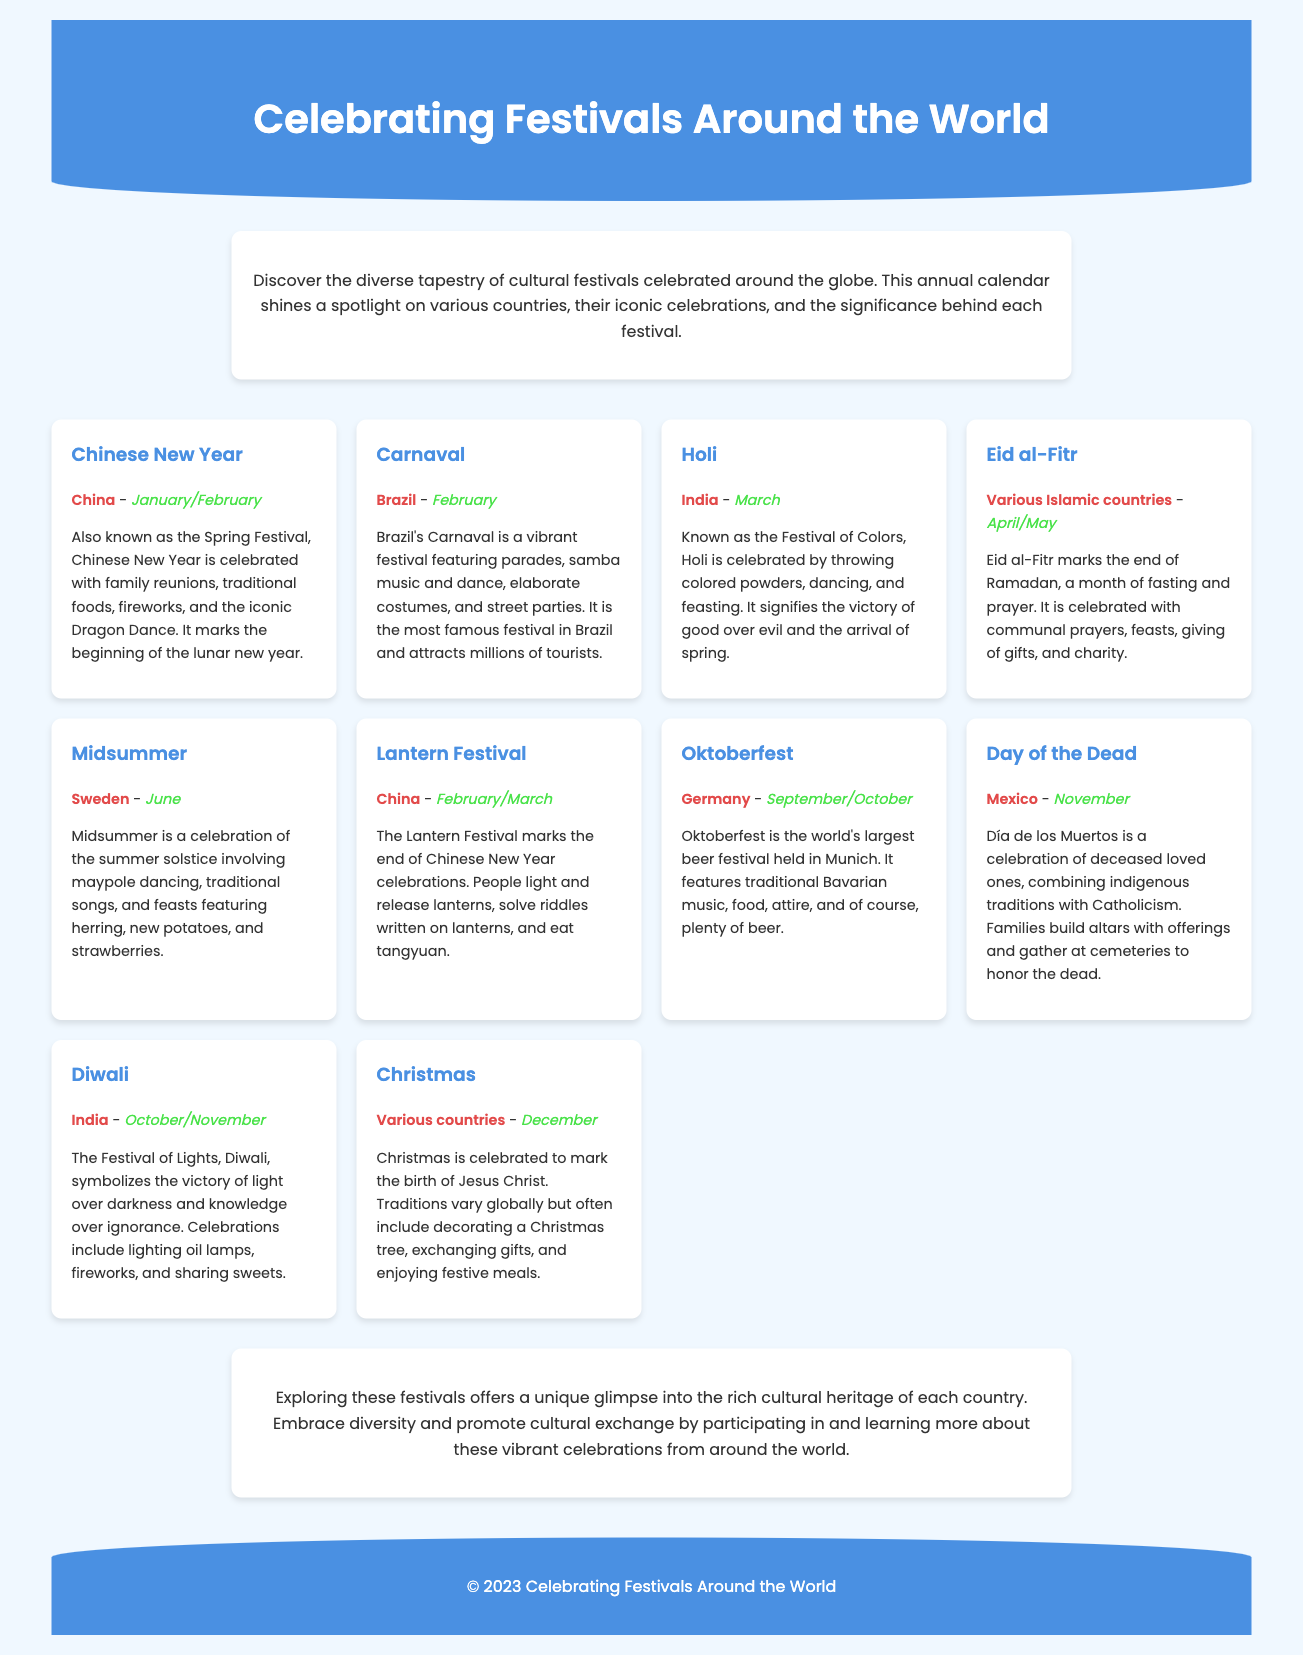what is the first festival listed? The first festival mentioned in the document is Chinese New Year.
Answer: Chinese New Year which country celebrates Holi? Holi is a festival celebrated in India.
Answer: India in which month does Carnaval occur? Carnaval takes place in February.
Answer: February what does Diwali symbolize? Diwali symbolizes the victory of light over darkness.
Answer: victory of light over darkness how many festivals are listed in total? The document lists ten cultural festivals.
Answer: ten which festival is celebrated in Mexico? The festival celebrated in Mexico is Day of the Dead.
Answer: Day of the Dead what is the common theme of the festivals highlighted? The common theme is the celebration of cultural heritage and diversity.
Answer: cultural heritage and diversity which month does Oktoberfest occur? Oktoberfest occurs in September/October.
Answer: September/October what is a unique feature of Eid al-Fitr celebrations? A unique feature of Eid al-Fitr is communal prayers and feasts.
Answer: communal prayers and feasts 